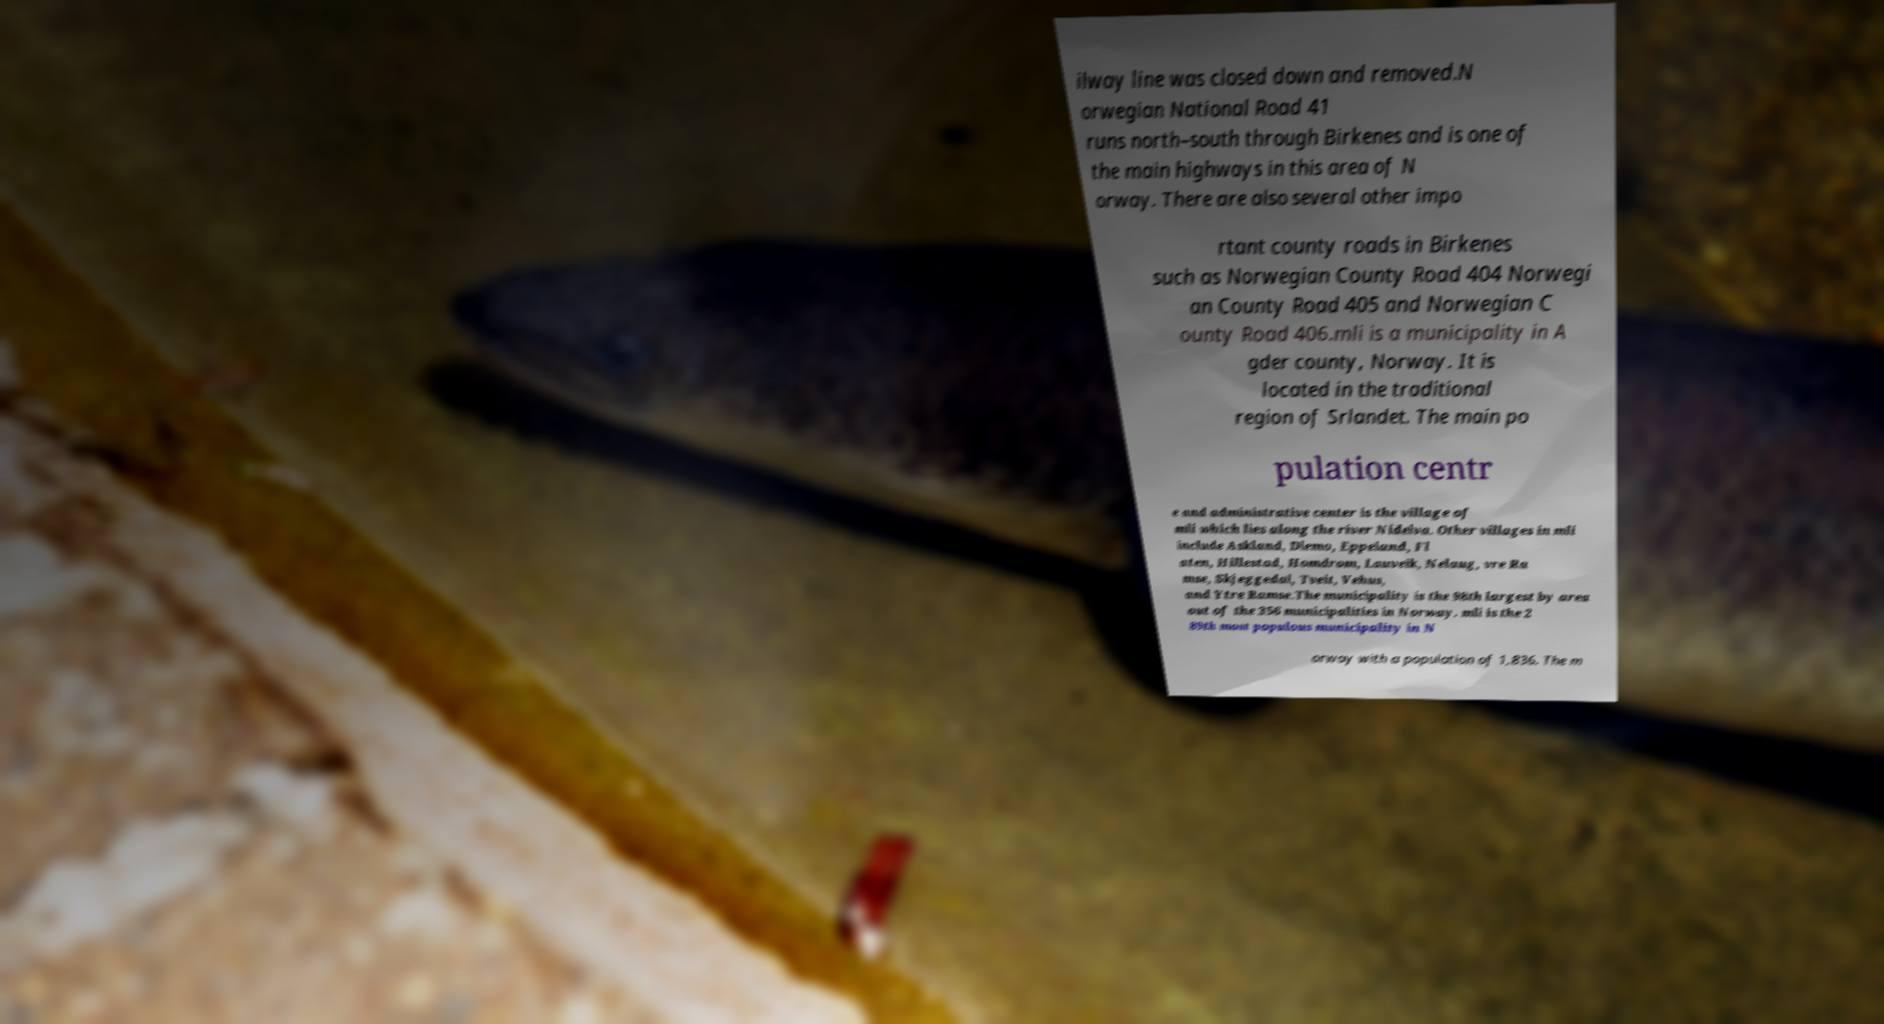I need the written content from this picture converted into text. Can you do that? ilway line was closed down and removed.N orwegian National Road 41 runs north–south through Birkenes and is one of the main highways in this area of N orway. There are also several other impo rtant county roads in Birkenes such as Norwegian County Road 404 Norwegi an County Road 405 and Norwegian C ounty Road 406.mli is a municipality in A gder county, Norway. It is located in the traditional region of Srlandet. The main po pulation centr e and administrative center is the village of mli which lies along the river Nidelva. Other villages in mli include Askland, Dlemo, Eppeland, Fl aten, Hillestad, Homdrom, Lauveik, Nelaug, vre Ra mse, Skjeggedal, Tveit, Vehus, and Ytre Ramse.The municipality is the 98th largest by area out of the 356 municipalities in Norway. mli is the 2 89th most populous municipality in N orway with a population of 1,836. The m 